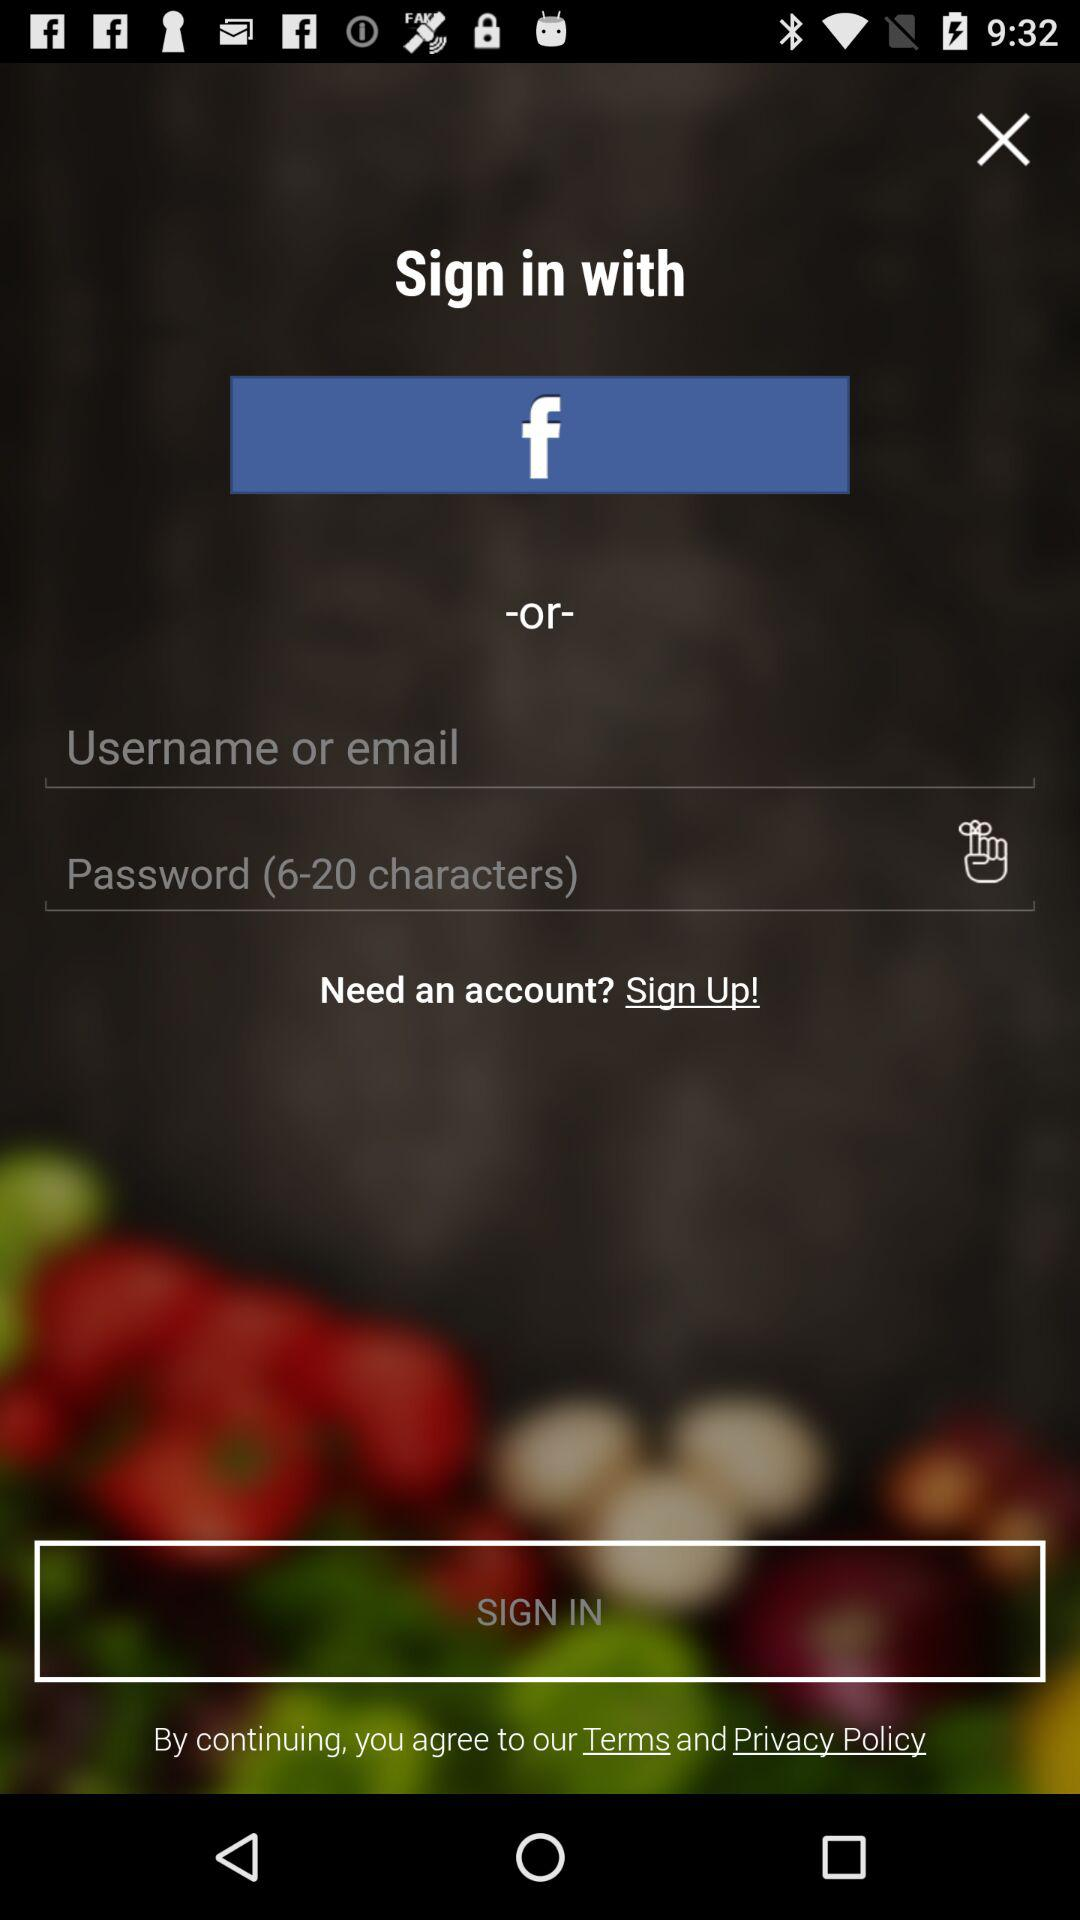What's the character limit for the password? The character limit for the password is 20. 